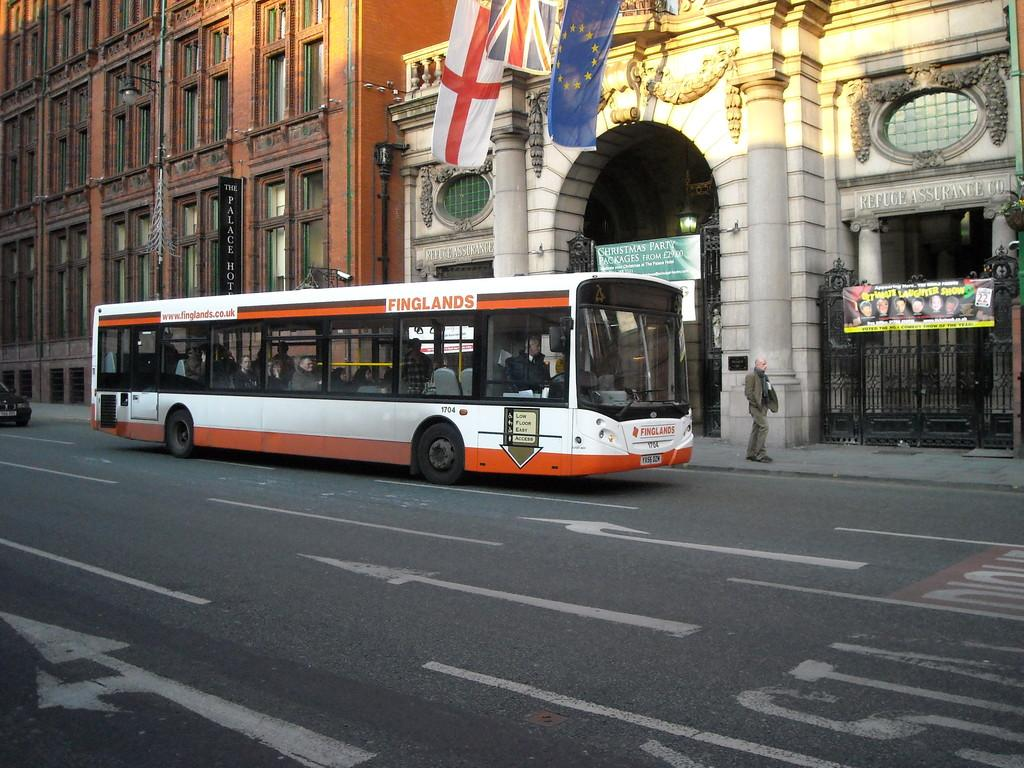What can be seen on the road in the image? There are vehicles on the road in the image. Is there anyone near the road in the image? Yes, there is a person visible near the road. What type of structure is present in the image? There is a metal gate in the image. What is on the buildings in the image? There are boards on the buildings in the image. What additional elements can be seen in the image? There are flags in the image. How many dogs are jumping in the image? There are no dogs present in the image. What decision can be seen being made by the person in the image? There is no decision-making process visible in the image; it only shows a person near the road. 